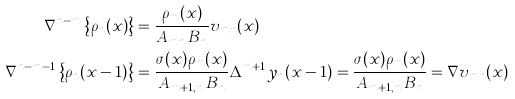<formula> <loc_0><loc_0><loc_500><loc_500>\nabla ^ { n - m } \left \{ { \rho _ { n } ( x ) } \right \} & = \frac { \rho _ { m } ( x ) } { { A _ { m n } \, B _ { n } } } v _ { m n } ( x ) \\ \nabla ^ { n - m - 1 } \left \{ { \rho _ { n } ( x - 1 ) } \right \} & = \frac { \sigma ( x ) \rho _ { m } ( x ) } { { A _ { m + 1 , n } \, B _ { n } } } \Delta ^ { m + 1 } y _ { n } ( x - 1 ) = \frac { \sigma ( x ) \rho _ { m } ( x ) } { { A _ { m + 1 , n } \, B _ { n } } } = \nabla { v _ { m n } ( x ) }</formula> 